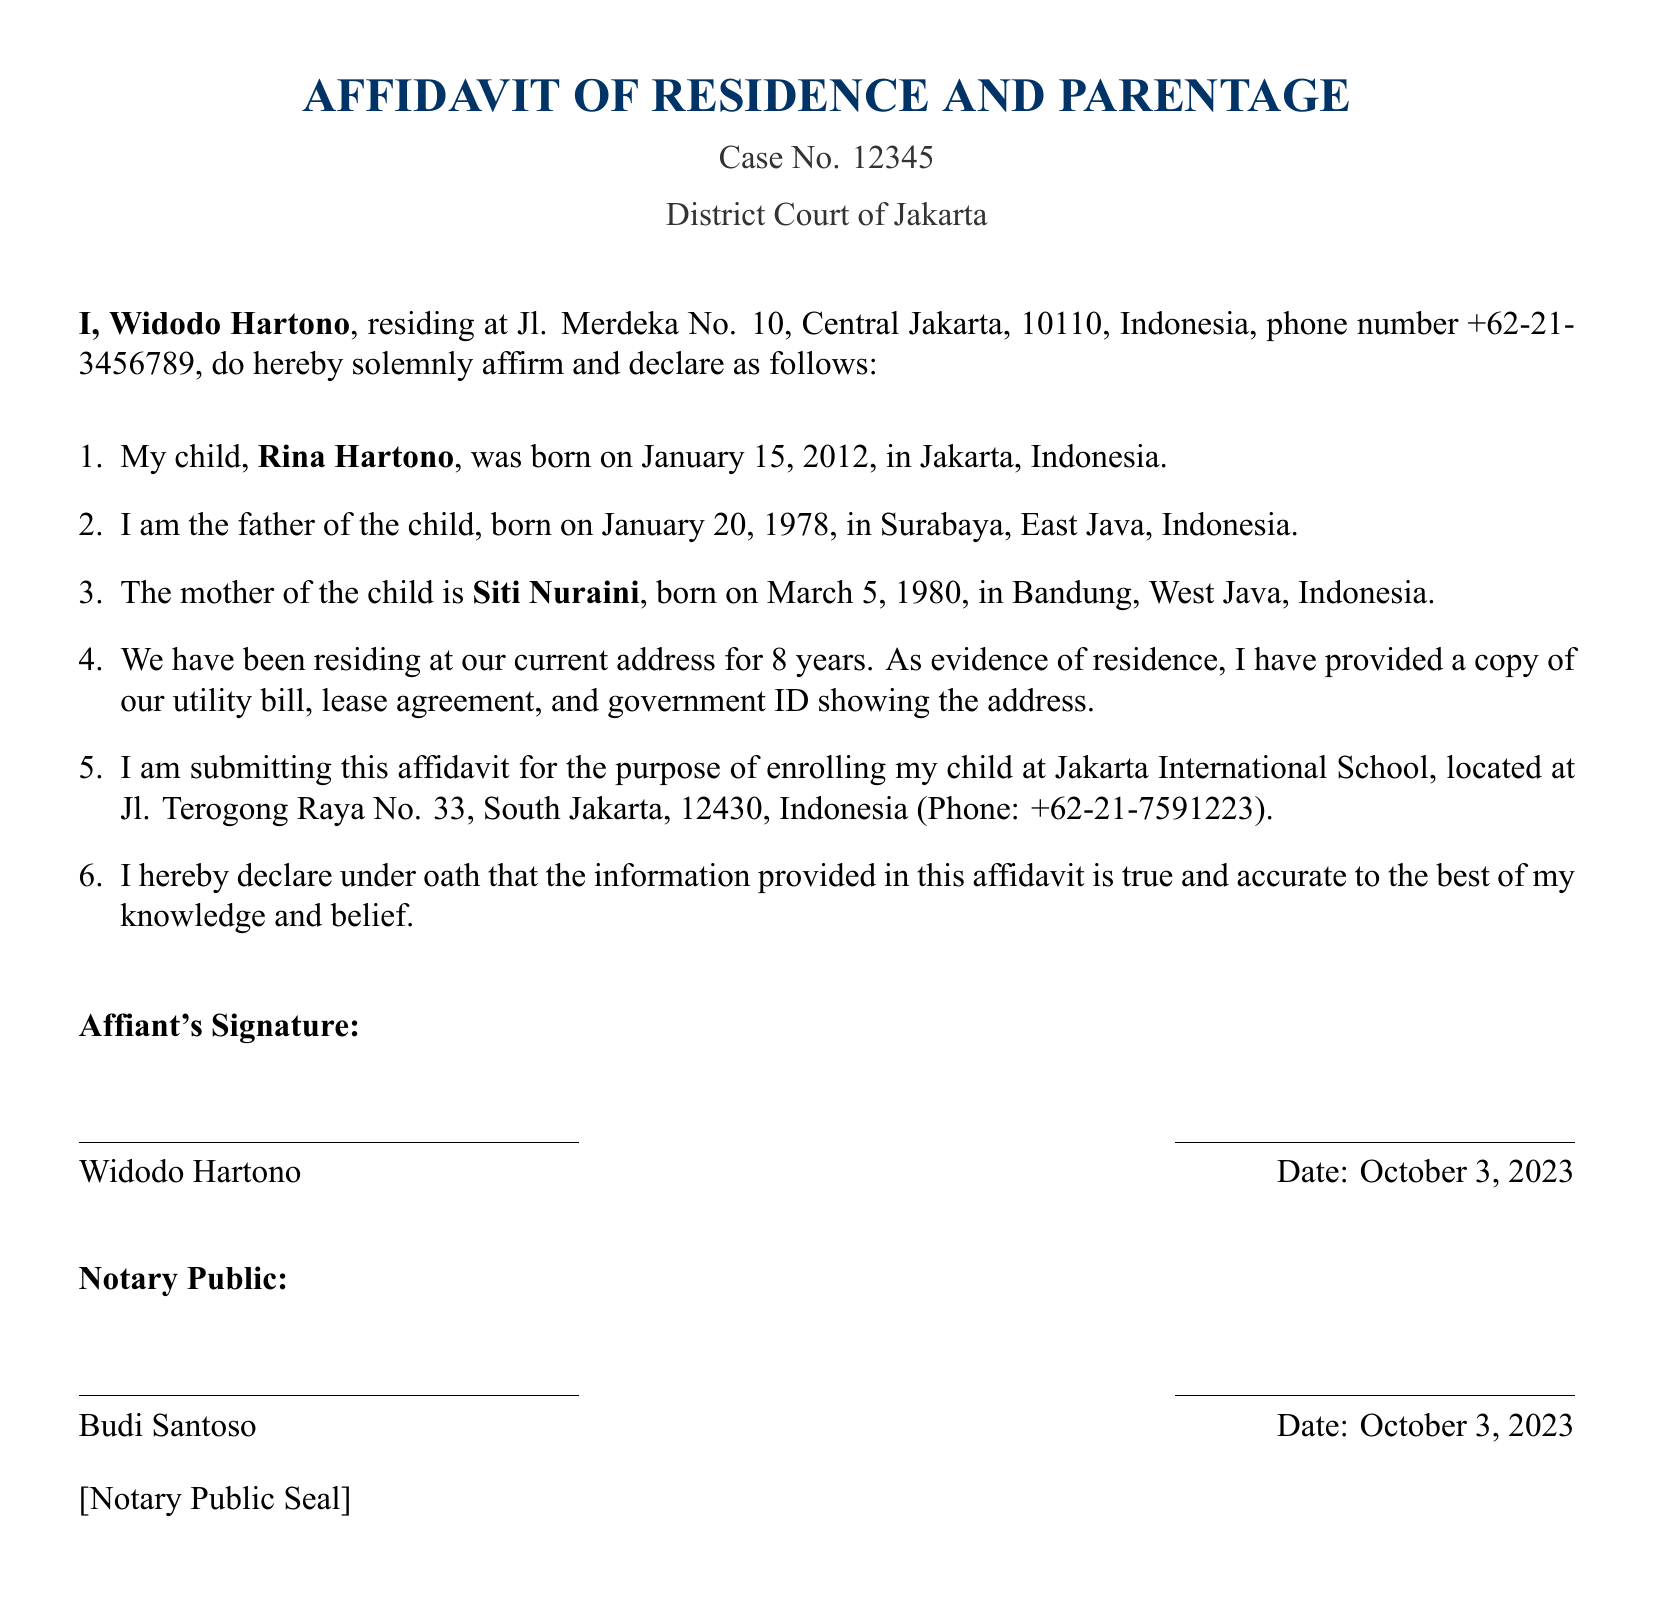What is the case number? The case number is mentioned at the top of the document for identification purposes, which is 12345.
Answer: 12345 Who is the affiant? The affiant is the person who makes the affidavit and declares their information, which is Widodo Hartono.
Answer: Widodo Hartono What is the child's name? The child's name is indicated in the document as the child of the affiant, which is Rina Hartono.
Answer: Rina Hartono Where does the affiant reside? The affiant's residence is specified in the document, listing the full address at Jl. Merdeka No. 10, Central Jakarta, 10110, Indonesia.
Answer: Jl. Merdeka No. 10, Central Jakarta, 10110, Indonesia What is the purpose of this affidavit? The affidavit serves a specific purpose, as stated in the document, which is to enroll the child at a school.
Answer: Enrolling at Jakarta International School Who is the child's mother? The document mentions the mother of the child, whose name is Siti Nuraini.
Answer: Siti Nuraini How long has the affiant lived at their current address? The document specifies the duration of residence at the current address, which is 8 years.
Answer: 8 years What is the date of the affidavit? The document includes the date when the affidavit was signed, which is October 3, 2023.
Answer: October 3, 2023 